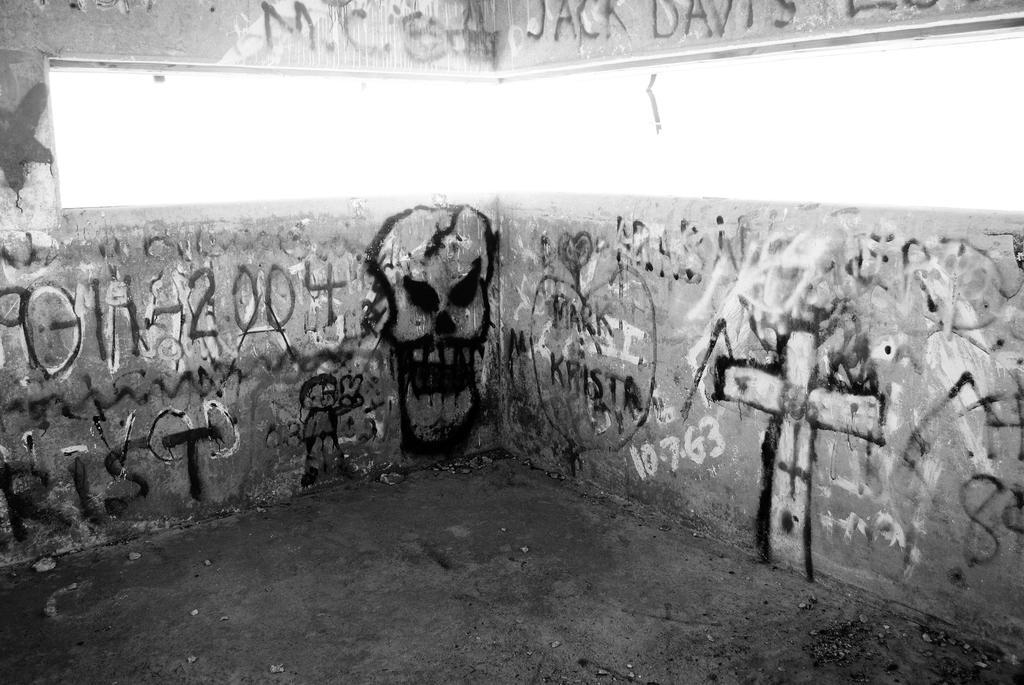How would you summarize this image in a sentence or two? In this image I can see the wall, window and something is written on it. I can see the painting on the wall and the image is in black and white. 